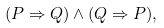Convert formula to latex. <formula><loc_0><loc_0><loc_500><loc_500>( P \Rightarrow Q ) \land ( Q \Rightarrow P ) ,</formula> 